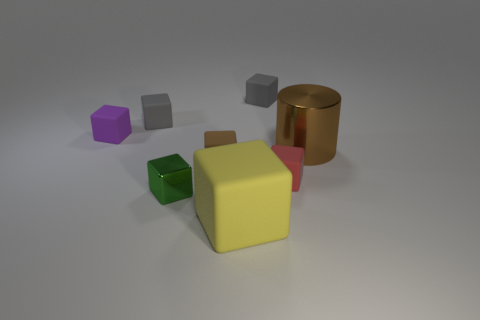There is a yellow thing that is the same shape as the tiny red matte thing; what is its size?
Offer a terse response. Large. What is the brown cube made of?
Give a very brief answer. Rubber. How many other objects are the same shape as the brown matte thing?
Your answer should be compact. 6. Is the red object the same shape as the tiny brown object?
Your response must be concise. Yes. What number of objects are either matte cubes to the left of the big yellow thing or tiny things that are on the left side of the large rubber thing?
Provide a succinct answer. 4. What number of objects are tiny red cubes or tiny purple objects?
Your answer should be very brief. 2. How many yellow rubber things are in front of the rubber object that is in front of the red block?
Your answer should be compact. 0. What number of other things are the same size as the purple rubber cube?
Offer a very short reply. 5. There is a shiny object that is on the left side of the yellow rubber object; does it have the same shape as the big rubber thing?
Offer a terse response. Yes. There is a large thing that is behind the big yellow matte block; what material is it?
Provide a succinct answer. Metal. 